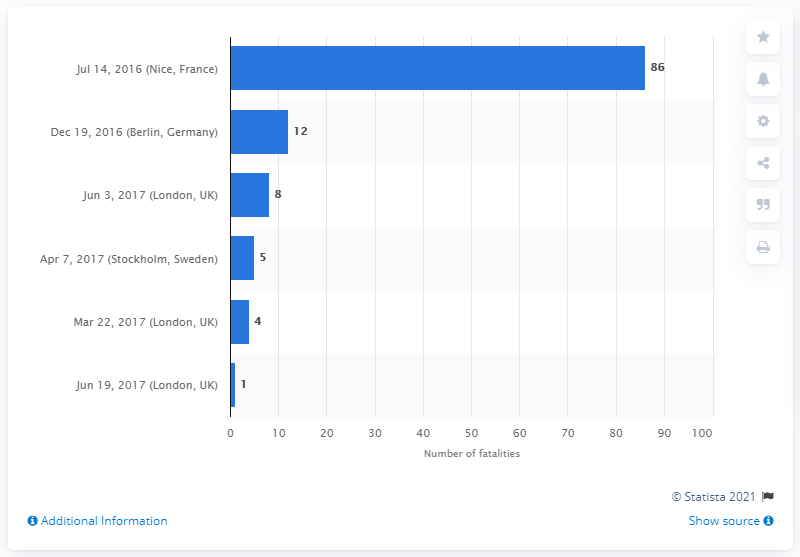List a handful of essential elements in this visual. On July 14th, 2016, 86 individuals, comprising of men, women, and children, lost their lives. 